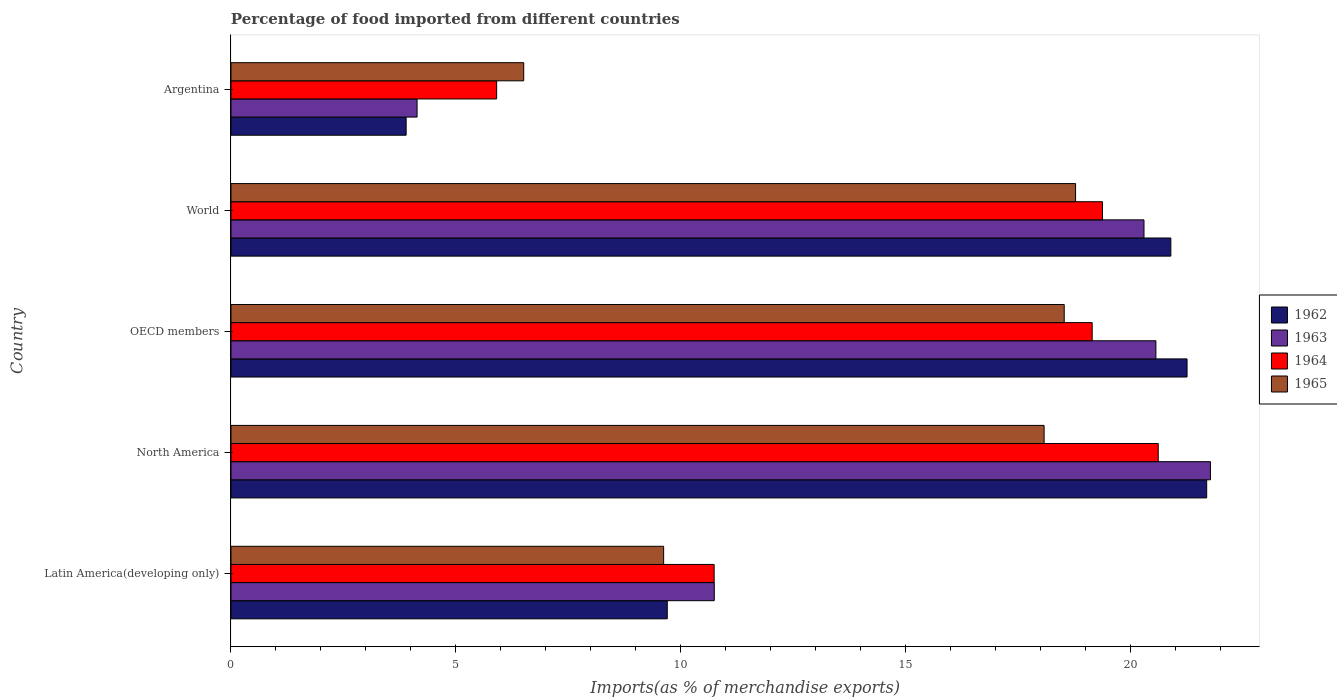How many different coloured bars are there?
Your response must be concise. 4. Are the number of bars per tick equal to the number of legend labels?
Ensure brevity in your answer.  Yes. Are the number of bars on each tick of the Y-axis equal?
Keep it short and to the point. Yes. What is the label of the 1st group of bars from the top?
Give a very brief answer. Argentina. What is the percentage of imports to different countries in 1965 in Latin America(developing only)?
Offer a terse response. 9.62. Across all countries, what is the maximum percentage of imports to different countries in 1963?
Your answer should be compact. 21.77. Across all countries, what is the minimum percentage of imports to different countries in 1965?
Give a very brief answer. 6.51. In which country was the percentage of imports to different countries in 1964 maximum?
Ensure brevity in your answer.  North America. In which country was the percentage of imports to different countries in 1964 minimum?
Offer a terse response. Argentina. What is the total percentage of imports to different countries in 1964 in the graph?
Provide a succinct answer. 75.77. What is the difference between the percentage of imports to different countries in 1965 in Argentina and that in World?
Your response must be concise. -12.27. What is the difference between the percentage of imports to different countries in 1964 in Argentina and the percentage of imports to different countries in 1962 in Latin America(developing only)?
Your answer should be very brief. -3.79. What is the average percentage of imports to different countries in 1963 per country?
Make the answer very short. 15.5. What is the difference between the percentage of imports to different countries in 1963 and percentage of imports to different countries in 1962 in Latin America(developing only)?
Keep it short and to the point. 1.05. What is the ratio of the percentage of imports to different countries in 1963 in Latin America(developing only) to that in North America?
Your response must be concise. 0.49. Is the percentage of imports to different countries in 1965 in Argentina less than that in North America?
Ensure brevity in your answer.  Yes. Is the difference between the percentage of imports to different countries in 1963 in Argentina and North America greater than the difference between the percentage of imports to different countries in 1962 in Argentina and North America?
Provide a short and direct response. Yes. What is the difference between the highest and the second highest percentage of imports to different countries in 1964?
Keep it short and to the point. 1.24. What is the difference between the highest and the lowest percentage of imports to different countries in 1964?
Ensure brevity in your answer.  14.71. In how many countries, is the percentage of imports to different countries in 1963 greater than the average percentage of imports to different countries in 1963 taken over all countries?
Make the answer very short. 3. Is it the case that in every country, the sum of the percentage of imports to different countries in 1964 and percentage of imports to different countries in 1965 is greater than the percentage of imports to different countries in 1962?
Keep it short and to the point. Yes. How many bars are there?
Give a very brief answer. 20. What is the difference between two consecutive major ticks on the X-axis?
Ensure brevity in your answer.  5. Are the values on the major ticks of X-axis written in scientific E-notation?
Your response must be concise. No. Does the graph contain any zero values?
Offer a very short reply. No. Does the graph contain grids?
Ensure brevity in your answer.  No. Where does the legend appear in the graph?
Give a very brief answer. Center right. How many legend labels are there?
Make the answer very short. 4. How are the legend labels stacked?
Keep it short and to the point. Vertical. What is the title of the graph?
Offer a very short reply. Percentage of food imported from different countries. Does "1968" appear as one of the legend labels in the graph?
Your answer should be compact. No. What is the label or title of the X-axis?
Provide a succinct answer. Imports(as % of merchandise exports). What is the Imports(as % of merchandise exports) of 1962 in Latin America(developing only)?
Keep it short and to the point. 9.7. What is the Imports(as % of merchandise exports) in 1963 in Latin America(developing only)?
Your answer should be very brief. 10.74. What is the Imports(as % of merchandise exports) in 1964 in Latin America(developing only)?
Ensure brevity in your answer.  10.74. What is the Imports(as % of merchandise exports) of 1965 in Latin America(developing only)?
Give a very brief answer. 9.62. What is the Imports(as % of merchandise exports) of 1962 in North America?
Your answer should be compact. 21.69. What is the Imports(as % of merchandise exports) of 1963 in North America?
Give a very brief answer. 21.77. What is the Imports(as % of merchandise exports) in 1964 in North America?
Provide a succinct answer. 20.61. What is the Imports(as % of merchandise exports) in 1965 in North America?
Your answer should be very brief. 18.07. What is the Imports(as % of merchandise exports) of 1962 in OECD members?
Your response must be concise. 21.25. What is the Imports(as % of merchandise exports) in 1963 in OECD members?
Ensure brevity in your answer.  20.56. What is the Imports(as % of merchandise exports) of 1964 in OECD members?
Keep it short and to the point. 19.14. What is the Imports(as % of merchandise exports) of 1965 in OECD members?
Provide a short and direct response. 18.52. What is the Imports(as % of merchandise exports) in 1962 in World?
Your response must be concise. 20.89. What is the Imports(as % of merchandise exports) of 1963 in World?
Your response must be concise. 20.29. What is the Imports(as % of merchandise exports) of 1964 in World?
Give a very brief answer. 19.37. What is the Imports(as % of merchandise exports) in 1965 in World?
Provide a short and direct response. 18.77. What is the Imports(as % of merchandise exports) of 1962 in Argentina?
Offer a very short reply. 3.89. What is the Imports(as % of merchandise exports) of 1963 in Argentina?
Offer a terse response. 4.14. What is the Imports(as % of merchandise exports) of 1964 in Argentina?
Ensure brevity in your answer.  5.91. What is the Imports(as % of merchandise exports) in 1965 in Argentina?
Ensure brevity in your answer.  6.51. Across all countries, what is the maximum Imports(as % of merchandise exports) of 1962?
Make the answer very short. 21.69. Across all countries, what is the maximum Imports(as % of merchandise exports) of 1963?
Offer a very short reply. 21.77. Across all countries, what is the maximum Imports(as % of merchandise exports) in 1964?
Make the answer very short. 20.61. Across all countries, what is the maximum Imports(as % of merchandise exports) in 1965?
Ensure brevity in your answer.  18.77. Across all countries, what is the minimum Imports(as % of merchandise exports) of 1962?
Keep it short and to the point. 3.89. Across all countries, what is the minimum Imports(as % of merchandise exports) of 1963?
Offer a terse response. 4.14. Across all countries, what is the minimum Imports(as % of merchandise exports) of 1964?
Give a very brief answer. 5.91. Across all countries, what is the minimum Imports(as % of merchandise exports) in 1965?
Give a very brief answer. 6.51. What is the total Imports(as % of merchandise exports) in 1962 in the graph?
Provide a short and direct response. 77.42. What is the total Imports(as % of merchandise exports) in 1963 in the graph?
Your answer should be compact. 77.5. What is the total Imports(as % of merchandise exports) of 1964 in the graph?
Provide a short and direct response. 75.77. What is the total Imports(as % of merchandise exports) in 1965 in the graph?
Your answer should be compact. 71.49. What is the difference between the Imports(as % of merchandise exports) of 1962 in Latin America(developing only) and that in North America?
Offer a very short reply. -11.99. What is the difference between the Imports(as % of merchandise exports) of 1963 in Latin America(developing only) and that in North America?
Provide a succinct answer. -11.03. What is the difference between the Imports(as % of merchandise exports) of 1964 in Latin America(developing only) and that in North America?
Provide a succinct answer. -9.87. What is the difference between the Imports(as % of merchandise exports) in 1965 in Latin America(developing only) and that in North America?
Offer a very short reply. -8.46. What is the difference between the Imports(as % of merchandise exports) in 1962 in Latin America(developing only) and that in OECD members?
Offer a very short reply. -11.55. What is the difference between the Imports(as % of merchandise exports) in 1963 in Latin America(developing only) and that in OECD members?
Provide a short and direct response. -9.82. What is the difference between the Imports(as % of merchandise exports) in 1964 in Latin America(developing only) and that in OECD members?
Give a very brief answer. -8.4. What is the difference between the Imports(as % of merchandise exports) in 1965 in Latin America(developing only) and that in OECD members?
Your answer should be compact. -8.9. What is the difference between the Imports(as % of merchandise exports) of 1962 in Latin America(developing only) and that in World?
Your response must be concise. -11.19. What is the difference between the Imports(as % of merchandise exports) of 1963 in Latin America(developing only) and that in World?
Offer a terse response. -9.55. What is the difference between the Imports(as % of merchandise exports) of 1964 in Latin America(developing only) and that in World?
Your answer should be compact. -8.63. What is the difference between the Imports(as % of merchandise exports) in 1965 in Latin America(developing only) and that in World?
Keep it short and to the point. -9.16. What is the difference between the Imports(as % of merchandise exports) in 1962 in Latin America(developing only) and that in Argentina?
Offer a terse response. 5.8. What is the difference between the Imports(as % of merchandise exports) in 1963 in Latin America(developing only) and that in Argentina?
Keep it short and to the point. 6.61. What is the difference between the Imports(as % of merchandise exports) in 1964 in Latin America(developing only) and that in Argentina?
Offer a very short reply. 4.83. What is the difference between the Imports(as % of merchandise exports) of 1965 in Latin America(developing only) and that in Argentina?
Offer a terse response. 3.11. What is the difference between the Imports(as % of merchandise exports) of 1962 in North America and that in OECD members?
Provide a succinct answer. 0.44. What is the difference between the Imports(as % of merchandise exports) in 1963 in North America and that in OECD members?
Provide a succinct answer. 1.21. What is the difference between the Imports(as % of merchandise exports) in 1964 in North America and that in OECD members?
Offer a terse response. 1.47. What is the difference between the Imports(as % of merchandise exports) in 1965 in North America and that in OECD members?
Offer a very short reply. -0.45. What is the difference between the Imports(as % of merchandise exports) in 1962 in North America and that in World?
Ensure brevity in your answer.  0.8. What is the difference between the Imports(as % of merchandise exports) in 1963 in North America and that in World?
Your response must be concise. 1.48. What is the difference between the Imports(as % of merchandise exports) of 1964 in North America and that in World?
Keep it short and to the point. 1.24. What is the difference between the Imports(as % of merchandise exports) in 1965 in North America and that in World?
Offer a terse response. -0.7. What is the difference between the Imports(as % of merchandise exports) in 1962 in North America and that in Argentina?
Provide a short and direct response. 17.79. What is the difference between the Imports(as % of merchandise exports) of 1963 in North America and that in Argentina?
Keep it short and to the point. 17.63. What is the difference between the Imports(as % of merchandise exports) in 1964 in North America and that in Argentina?
Provide a short and direct response. 14.71. What is the difference between the Imports(as % of merchandise exports) of 1965 in North America and that in Argentina?
Your answer should be compact. 11.57. What is the difference between the Imports(as % of merchandise exports) in 1962 in OECD members and that in World?
Your answer should be very brief. 0.36. What is the difference between the Imports(as % of merchandise exports) in 1963 in OECD members and that in World?
Keep it short and to the point. 0.26. What is the difference between the Imports(as % of merchandise exports) of 1964 in OECD members and that in World?
Offer a very short reply. -0.23. What is the difference between the Imports(as % of merchandise exports) in 1965 in OECD members and that in World?
Make the answer very short. -0.25. What is the difference between the Imports(as % of merchandise exports) of 1962 in OECD members and that in Argentina?
Provide a succinct answer. 17.36. What is the difference between the Imports(as % of merchandise exports) of 1963 in OECD members and that in Argentina?
Your answer should be compact. 16.42. What is the difference between the Imports(as % of merchandise exports) of 1964 in OECD members and that in Argentina?
Provide a succinct answer. 13.24. What is the difference between the Imports(as % of merchandise exports) of 1965 in OECD members and that in Argentina?
Offer a very short reply. 12.01. What is the difference between the Imports(as % of merchandise exports) in 1962 in World and that in Argentina?
Offer a terse response. 17. What is the difference between the Imports(as % of merchandise exports) of 1963 in World and that in Argentina?
Your answer should be compact. 16.16. What is the difference between the Imports(as % of merchandise exports) in 1964 in World and that in Argentina?
Keep it short and to the point. 13.47. What is the difference between the Imports(as % of merchandise exports) in 1965 in World and that in Argentina?
Provide a short and direct response. 12.27. What is the difference between the Imports(as % of merchandise exports) in 1962 in Latin America(developing only) and the Imports(as % of merchandise exports) in 1963 in North America?
Your response must be concise. -12.07. What is the difference between the Imports(as % of merchandise exports) of 1962 in Latin America(developing only) and the Imports(as % of merchandise exports) of 1964 in North America?
Provide a short and direct response. -10.91. What is the difference between the Imports(as % of merchandise exports) in 1962 in Latin America(developing only) and the Imports(as % of merchandise exports) in 1965 in North America?
Offer a terse response. -8.38. What is the difference between the Imports(as % of merchandise exports) in 1963 in Latin America(developing only) and the Imports(as % of merchandise exports) in 1964 in North America?
Provide a short and direct response. -9.87. What is the difference between the Imports(as % of merchandise exports) of 1963 in Latin America(developing only) and the Imports(as % of merchandise exports) of 1965 in North America?
Make the answer very short. -7.33. What is the difference between the Imports(as % of merchandise exports) in 1964 in Latin America(developing only) and the Imports(as % of merchandise exports) in 1965 in North America?
Offer a terse response. -7.33. What is the difference between the Imports(as % of merchandise exports) of 1962 in Latin America(developing only) and the Imports(as % of merchandise exports) of 1963 in OECD members?
Ensure brevity in your answer.  -10.86. What is the difference between the Imports(as % of merchandise exports) in 1962 in Latin America(developing only) and the Imports(as % of merchandise exports) in 1964 in OECD members?
Make the answer very short. -9.44. What is the difference between the Imports(as % of merchandise exports) in 1962 in Latin America(developing only) and the Imports(as % of merchandise exports) in 1965 in OECD members?
Offer a terse response. -8.82. What is the difference between the Imports(as % of merchandise exports) in 1963 in Latin America(developing only) and the Imports(as % of merchandise exports) in 1964 in OECD members?
Keep it short and to the point. -8.4. What is the difference between the Imports(as % of merchandise exports) in 1963 in Latin America(developing only) and the Imports(as % of merchandise exports) in 1965 in OECD members?
Ensure brevity in your answer.  -7.78. What is the difference between the Imports(as % of merchandise exports) in 1964 in Latin America(developing only) and the Imports(as % of merchandise exports) in 1965 in OECD members?
Ensure brevity in your answer.  -7.78. What is the difference between the Imports(as % of merchandise exports) of 1962 in Latin America(developing only) and the Imports(as % of merchandise exports) of 1963 in World?
Give a very brief answer. -10.6. What is the difference between the Imports(as % of merchandise exports) in 1962 in Latin America(developing only) and the Imports(as % of merchandise exports) in 1964 in World?
Your answer should be compact. -9.67. What is the difference between the Imports(as % of merchandise exports) in 1962 in Latin America(developing only) and the Imports(as % of merchandise exports) in 1965 in World?
Ensure brevity in your answer.  -9.08. What is the difference between the Imports(as % of merchandise exports) of 1963 in Latin America(developing only) and the Imports(as % of merchandise exports) of 1964 in World?
Provide a succinct answer. -8.63. What is the difference between the Imports(as % of merchandise exports) of 1963 in Latin America(developing only) and the Imports(as % of merchandise exports) of 1965 in World?
Make the answer very short. -8.03. What is the difference between the Imports(as % of merchandise exports) of 1964 in Latin America(developing only) and the Imports(as % of merchandise exports) of 1965 in World?
Keep it short and to the point. -8.03. What is the difference between the Imports(as % of merchandise exports) in 1962 in Latin America(developing only) and the Imports(as % of merchandise exports) in 1963 in Argentina?
Your answer should be very brief. 5.56. What is the difference between the Imports(as % of merchandise exports) of 1962 in Latin America(developing only) and the Imports(as % of merchandise exports) of 1964 in Argentina?
Offer a terse response. 3.79. What is the difference between the Imports(as % of merchandise exports) in 1962 in Latin America(developing only) and the Imports(as % of merchandise exports) in 1965 in Argentina?
Provide a short and direct response. 3.19. What is the difference between the Imports(as % of merchandise exports) of 1963 in Latin America(developing only) and the Imports(as % of merchandise exports) of 1964 in Argentina?
Your answer should be very brief. 4.84. What is the difference between the Imports(as % of merchandise exports) in 1963 in Latin America(developing only) and the Imports(as % of merchandise exports) in 1965 in Argentina?
Give a very brief answer. 4.24. What is the difference between the Imports(as % of merchandise exports) in 1964 in Latin America(developing only) and the Imports(as % of merchandise exports) in 1965 in Argentina?
Provide a short and direct response. 4.23. What is the difference between the Imports(as % of merchandise exports) of 1962 in North America and the Imports(as % of merchandise exports) of 1963 in OECD members?
Provide a short and direct response. 1.13. What is the difference between the Imports(as % of merchandise exports) of 1962 in North America and the Imports(as % of merchandise exports) of 1964 in OECD members?
Make the answer very short. 2.55. What is the difference between the Imports(as % of merchandise exports) of 1962 in North America and the Imports(as % of merchandise exports) of 1965 in OECD members?
Give a very brief answer. 3.17. What is the difference between the Imports(as % of merchandise exports) of 1963 in North America and the Imports(as % of merchandise exports) of 1964 in OECD members?
Make the answer very short. 2.63. What is the difference between the Imports(as % of merchandise exports) of 1963 in North America and the Imports(as % of merchandise exports) of 1965 in OECD members?
Give a very brief answer. 3.25. What is the difference between the Imports(as % of merchandise exports) of 1964 in North America and the Imports(as % of merchandise exports) of 1965 in OECD members?
Your answer should be very brief. 2.09. What is the difference between the Imports(as % of merchandise exports) of 1962 in North America and the Imports(as % of merchandise exports) of 1963 in World?
Your answer should be compact. 1.39. What is the difference between the Imports(as % of merchandise exports) in 1962 in North America and the Imports(as % of merchandise exports) in 1964 in World?
Give a very brief answer. 2.32. What is the difference between the Imports(as % of merchandise exports) in 1962 in North America and the Imports(as % of merchandise exports) in 1965 in World?
Give a very brief answer. 2.91. What is the difference between the Imports(as % of merchandise exports) in 1963 in North America and the Imports(as % of merchandise exports) in 1964 in World?
Your response must be concise. 2.4. What is the difference between the Imports(as % of merchandise exports) of 1963 in North America and the Imports(as % of merchandise exports) of 1965 in World?
Your answer should be very brief. 3. What is the difference between the Imports(as % of merchandise exports) of 1964 in North America and the Imports(as % of merchandise exports) of 1965 in World?
Your answer should be very brief. 1.84. What is the difference between the Imports(as % of merchandise exports) in 1962 in North America and the Imports(as % of merchandise exports) in 1963 in Argentina?
Offer a very short reply. 17.55. What is the difference between the Imports(as % of merchandise exports) in 1962 in North America and the Imports(as % of merchandise exports) in 1964 in Argentina?
Provide a succinct answer. 15.78. What is the difference between the Imports(as % of merchandise exports) in 1962 in North America and the Imports(as % of merchandise exports) in 1965 in Argentina?
Give a very brief answer. 15.18. What is the difference between the Imports(as % of merchandise exports) of 1963 in North America and the Imports(as % of merchandise exports) of 1964 in Argentina?
Offer a very short reply. 15.87. What is the difference between the Imports(as % of merchandise exports) in 1963 in North America and the Imports(as % of merchandise exports) in 1965 in Argentina?
Give a very brief answer. 15.26. What is the difference between the Imports(as % of merchandise exports) of 1964 in North America and the Imports(as % of merchandise exports) of 1965 in Argentina?
Your answer should be very brief. 14.1. What is the difference between the Imports(as % of merchandise exports) in 1962 in OECD members and the Imports(as % of merchandise exports) in 1963 in World?
Ensure brevity in your answer.  0.96. What is the difference between the Imports(as % of merchandise exports) of 1962 in OECD members and the Imports(as % of merchandise exports) of 1964 in World?
Ensure brevity in your answer.  1.88. What is the difference between the Imports(as % of merchandise exports) in 1962 in OECD members and the Imports(as % of merchandise exports) in 1965 in World?
Your response must be concise. 2.48. What is the difference between the Imports(as % of merchandise exports) of 1963 in OECD members and the Imports(as % of merchandise exports) of 1964 in World?
Keep it short and to the point. 1.19. What is the difference between the Imports(as % of merchandise exports) of 1963 in OECD members and the Imports(as % of merchandise exports) of 1965 in World?
Provide a short and direct response. 1.78. What is the difference between the Imports(as % of merchandise exports) in 1964 in OECD members and the Imports(as % of merchandise exports) in 1965 in World?
Your answer should be very brief. 0.37. What is the difference between the Imports(as % of merchandise exports) of 1962 in OECD members and the Imports(as % of merchandise exports) of 1963 in Argentina?
Give a very brief answer. 17.11. What is the difference between the Imports(as % of merchandise exports) of 1962 in OECD members and the Imports(as % of merchandise exports) of 1964 in Argentina?
Your answer should be very brief. 15.35. What is the difference between the Imports(as % of merchandise exports) in 1962 in OECD members and the Imports(as % of merchandise exports) in 1965 in Argentina?
Keep it short and to the point. 14.74. What is the difference between the Imports(as % of merchandise exports) in 1963 in OECD members and the Imports(as % of merchandise exports) in 1964 in Argentina?
Your answer should be compact. 14.65. What is the difference between the Imports(as % of merchandise exports) of 1963 in OECD members and the Imports(as % of merchandise exports) of 1965 in Argentina?
Your answer should be very brief. 14.05. What is the difference between the Imports(as % of merchandise exports) in 1964 in OECD members and the Imports(as % of merchandise exports) in 1965 in Argentina?
Your answer should be compact. 12.64. What is the difference between the Imports(as % of merchandise exports) in 1962 in World and the Imports(as % of merchandise exports) in 1963 in Argentina?
Provide a succinct answer. 16.75. What is the difference between the Imports(as % of merchandise exports) in 1962 in World and the Imports(as % of merchandise exports) in 1964 in Argentina?
Provide a succinct answer. 14.99. What is the difference between the Imports(as % of merchandise exports) in 1962 in World and the Imports(as % of merchandise exports) in 1965 in Argentina?
Offer a very short reply. 14.38. What is the difference between the Imports(as % of merchandise exports) of 1963 in World and the Imports(as % of merchandise exports) of 1964 in Argentina?
Your answer should be compact. 14.39. What is the difference between the Imports(as % of merchandise exports) in 1963 in World and the Imports(as % of merchandise exports) in 1965 in Argentina?
Keep it short and to the point. 13.79. What is the difference between the Imports(as % of merchandise exports) of 1964 in World and the Imports(as % of merchandise exports) of 1965 in Argentina?
Provide a succinct answer. 12.86. What is the average Imports(as % of merchandise exports) of 1962 per country?
Give a very brief answer. 15.48. What is the average Imports(as % of merchandise exports) in 1963 per country?
Provide a short and direct response. 15.5. What is the average Imports(as % of merchandise exports) in 1964 per country?
Keep it short and to the point. 15.15. What is the average Imports(as % of merchandise exports) of 1965 per country?
Provide a succinct answer. 14.3. What is the difference between the Imports(as % of merchandise exports) of 1962 and Imports(as % of merchandise exports) of 1963 in Latin America(developing only)?
Your response must be concise. -1.05. What is the difference between the Imports(as % of merchandise exports) of 1962 and Imports(as % of merchandise exports) of 1964 in Latin America(developing only)?
Provide a succinct answer. -1.04. What is the difference between the Imports(as % of merchandise exports) of 1962 and Imports(as % of merchandise exports) of 1965 in Latin America(developing only)?
Provide a short and direct response. 0.08. What is the difference between the Imports(as % of merchandise exports) in 1963 and Imports(as % of merchandise exports) in 1964 in Latin America(developing only)?
Your answer should be compact. 0. What is the difference between the Imports(as % of merchandise exports) of 1963 and Imports(as % of merchandise exports) of 1965 in Latin America(developing only)?
Give a very brief answer. 1.13. What is the difference between the Imports(as % of merchandise exports) in 1964 and Imports(as % of merchandise exports) in 1965 in Latin America(developing only)?
Your answer should be very brief. 1.12. What is the difference between the Imports(as % of merchandise exports) in 1962 and Imports(as % of merchandise exports) in 1963 in North America?
Keep it short and to the point. -0.08. What is the difference between the Imports(as % of merchandise exports) of 1962 and Imports(as % of merchandise exports) of 1964 in North America?
Your answer should be compact. 1.08. What is the difference between the Imports(as % of merchandise exports) in 1962 and Imports(as % of merchandise exports) in 1965 in North America?
Your answer should be compact. 3.61. What is the difference between the Imports(as % of merchandise exports) of 1963 and Imports(as % of merchandise exports) of 1964 in North America?
Keep it short and to the point. 1.16. What is the difference between the Imports(as % of merchandise exports) in 1963 and Imports(as % of merchandise exports) in 1965 in North America?
Offer a terse response. 3.7. What is the difference between the Imports(as % of merchandise exports) in 1964 and Imports(as % of merchandise exports) in 1965 in North America?
Your response must be concise. 2.54. What is the difference between the Imports(as % of merchandise exports) in 1962 and Imports(as % of merchandise exports) in 1963 in OECD members?
Offer a very short reply. 0.69. What is the difference between the Imports(as % of merchandise exports) of 1962 and Imports(as % of merchandise exports) of 1964 in OECD members?
Provide a short and direct response. 2.11. What is the difference between the Imports(as % of merchandise exports) of 1962 and Imports(as % of merchandise exports) of 1965 in OECD members?
Your answer should be compact. 2.73. What is the difference between the Imports(as % of merchandise exports) in 1963 and Imports(as % of merchandise exports) in 1964 in OECD members?
Provide a succinct answer. 1.42. What is the difference between the Imports(as % of merchandise exports) of 1963 and Imports(as % of merchandise exports) of 1965 in OECD members?
Your response must be concise. 2.04. What is the difference between the Imports(as % of merchandise exports) in 1964 and Imports(as % of merchandise exports) in 1965 in OECD members?
Provide a succinct answer. 0.62. What is the difference between the Imports(as % of merchandise exports) in 1962 and Imports(as % of merchandise exports) in 1963 in World?
Your answer should be compact. 0.6. What is the difference between the Imports(as % of merchandise exports) in 1962 and Imports(as % of merchandise exports) in 1964 in World?
Give a very brief answer. 1.52. What is the difference between the Imports(as % of merchandise exports) in 1962 and Imports(as % of merchandise exports) in 1965 in World?
Your answer should be compact. 2.12. What is the difference between the Imports(as % of merchandise exports) of 1963 and Imports(as % of merchandise exports) of 1964 in World?
Give a very brief answer. 0.92. What is the difference between the Imports(as % of merchandise exports) of 1963 and Imports(as % of merchandise exports) of 1965 in World?
Give a very brief answer. 1.52. What is the difference between the Imports(as % of merchandise exports) of 1964 and Imports(as % of merchandise exports) of 1965 in World?
Make the answer very short. 0.6. What is the difference between the Imports(as % of merchandise exports) of 1962 and Imports(as % of merchandise exports) of 1963 in Argentina?
Keep it short and to the point. -0.24. What is the difference between the Imports(as % of merchandise exports) in 1962 and Imports(as % of merchandise exports) in 1964 in Argentina?
Offer a very short reply. -2.01. What is the difference between the Imports(as % of merchandise exports) in 1962 and Imports(as % of merchandise exports) in 1965 in Argentina?
Your answer should be compact. -2.61. What is the difference between the Imports(as % of merchandise exports) in 1963 and Imports(as % of merchandise exports) in 1964 in Argentina?
Offer a terse response. -1.77. What is the difference between the Imports(as % of merchandise exports) in 1963 and Imports(as % of merchandise exports) in 1965 in Argentina?
Ensure brevity in your answer.  -2.37. What is the difference between the Imports(as % of merchandise exports) of 1964 and Imports(as % of merchandise exports) of 1965 in Argentina?
Ensure brevity in your answer.  -0.6. What is the ratio of the Imports(as % of merchandise exports) in 1962 in Latin America(developing only) to that in North America?
Your answer should be very brief. 0.45. What is the ratio of the Imports(as % of merchandise exports) of 1963 in Latin America(developing only) to that in North America?
Your answer should be compact. 0.49. What is the ratio of the Imports(as % of merchandise exports) of 1964 in Latin America(developing only) to that in North America?
Offer a terse response. 0.52. What is the ratio of the Imports(as % of merchandise exports) of 1965 in Latin America(developing only) to that in North America?
Offer a terse response. 0.53. What is the ratio of the Imports(as % of merchandise exports) in 1962 in Latin America(developing only) to that in OECD members?
Ensure brevity in your answer.  0.46. What is the ratio of the Imports(as % of merchandise exports) in 1963 in Latin America(developing only) to that in OECD members?
Your answer should be compact. 0.52. What is the ratio of the Imports(as % of merchandise exports) of 1964 in Latin America(developing only) to that in OECD members?
Keep it short and to the point. 0.56. What is the ratio of the Imports(as % of merchandise exports) in 1965 in Latin America(developing only) to that in OECD members?
Keep it short and to the point. 0.52. What is the ratio of the Imports(as % of merchandise exports) in 1962 in Latin America(developing only) to that in World?
Your answer should be very brief. 0.46. What is the ratio of the Imports(as % of merchandise exports) in 1963 in Latin America(developing only) to that in World?
Make the answer very short. 0.53. What is the ratio of the Imports(as % of merchandise exports) of 1964 in Latin America(developing only) to that in World?
Ensure brevity in your answer.  0.55. What is the ratio of the Imports(as % of merchandise exports) in 1965 in Latin America(developing only) to that in World?
Your answer should be very brief. 0.51. What is the ratio of the Imports(as % of merchandise exports) in 1962 in Latin America(developing only) to that in Argentina?
Your answer should be very brief. 2.49. What is the ratio of the Imports(as % of merchandise exports) of 1963 in Latin America(developing only) to that in Argentina?
Keep it short and to the point. 2.6. What is the ratio of the Imports(as % of merchandise exports) of 1964 in Latin America(developing only) to that in Argentina?
Offer a terse response. 1.82. What is the ratio of the Imports(as % of merchandise exports) in 1965 in Latin America(developing only) to that in Argentina?
Your answer should be very brief. 1.48. What is the ratio of the Imports(as % of merchandise exports) of 1962 in North America to that in OECD members?
Your answer should be very brief. 1.02. What is the ratio of the Imports(as % of merchandise exports) of 1963 in North America to that in OECD members?
Offer a terse response. 1.06. What is the ratio of the Imports(as % of merchandise exports) of 1964 in North America to that in OECD members?
Offer a terse response. 1.08. What is the ratio of the Imports(as % of merchandise exports) of 1965 in North America to that in OECD members?
Ensure brevity in your answer.  0.98. What is the ratio of the Imports(as % of merchandise exports) in 1962 in North America to that in World?
Offer a very short reply. 1.04. What is the ratio of the Imports(as % of merchandise exports) in 1963 in North America to that in World?
Offer a very short reply. 1.07. What is the ratio of the Imports(as % of merchandise exports) of 1964 in North America to that in World?
Keep it short and to the point. 1.06. What is the ratio of the Imports(as % of merchandise exports) of 1965 in North America to that in World?
Offer a very short reply. 0.96. What is the ratio of the Imports(as % of merchandise exports) of 1962 in North America to that in Argentina?
Provide a succinct answer. 5.57. What is the ratio of the Imports(as % of merchandise exports) of 1963 in North America to that in Argentina?
Your answer should be compact. 5.26. What is the ratio of the Imports(as % of merchandise exports) of 1964 in North America to that in Argentina?
Give a very brief answer. 3.49. What is the ratio of the Imports(as % of merchandise exports) in 1965 in North America to that in Argentina?
Your answer should be very brief. 2.78. What is the ratio of the Imports(as % of merchandise exports) in 1962 in OECD members to that in World?
Make the answer very short. 1.02. What is the ratio of the Imports(as % of merchandise exports) of 1963 in OECD members to that in World?
Offer a very short reply. 1.01. What is the ratio of the Imports(as % of merchandise exports) in 1965 in OECD members to that in World?
Ensure brevity in your answer.  0.99. What is the ratio of the Imports(as % of merchandise exports) of 1962 in OECD members to that in Argentina?
Your answer should be compact. 5.46. What is the ratio of the Imports(as % of merchandise exports) in 1963 in OECD members to that in Argentina?
Offer a terse response. 4.97. What is the ratio of the Imports(as % of merchandise exports) of 1964 in OECD members to that in Argentina?
Offer a terse response. 3.24. What is the ratio of the Imports(as % of merchandise exports) in 1965 in OECD members to that in Argentina?
Your answer should be compact. 2.85. What is the ratio of the Imports(as % of merchandise exports) in 1962 in World to that in Argentina?
Offer a terse response. 5.37. What is the ratio of the Imports(as % of merchandise exports) of 1963 in World to that in Argentina?
Provide a succinct answer. 4.91. What is the ratio of the Imports(as % of merchandise exports) in 1964 in World to that in Argentina?
Give a very brief answer. 3.28. What is the ratio of the Imports(as % of merchandise exports) in 1965 in World to that in Argentina?
Offer a terse response. 2.89. What is the difference between the highest and the second highest Imports(as % of merchandise exports) in 1962?
Ensure brevity in your answer.  0.44. What is the difference between the highest and the second highest Imports(as % of merchandise exports) in 1963?
Your answer should be compact. 1.21. What is the difference between the highest and the second highest Imports(as % of merchandise exports) of 1964?
Make the answer very short. 1.24. What is the difference between the highest and the second highest Imports(as % of merchandise exports) in 1965?
Your answer should be very brief. 0.25. What is the difference between the highest and the lowest Imports(as % of merchandise exports) of 1962?
Offer a terse response. 17.79. What is the difference between the highest and the lowest Imports(as % of merchandise exports) in 1963?
Offer a very short reply. 17.63. What is the difference between the highest and the lowest Imports(as % of merchandise exports) in 1964?
Ensure brevity in your answer.  14.71. What is the difference between the highest and the lowest Imports(as % of merchandise exports) in 1965?
Provide a succinct answer. 12.27. 